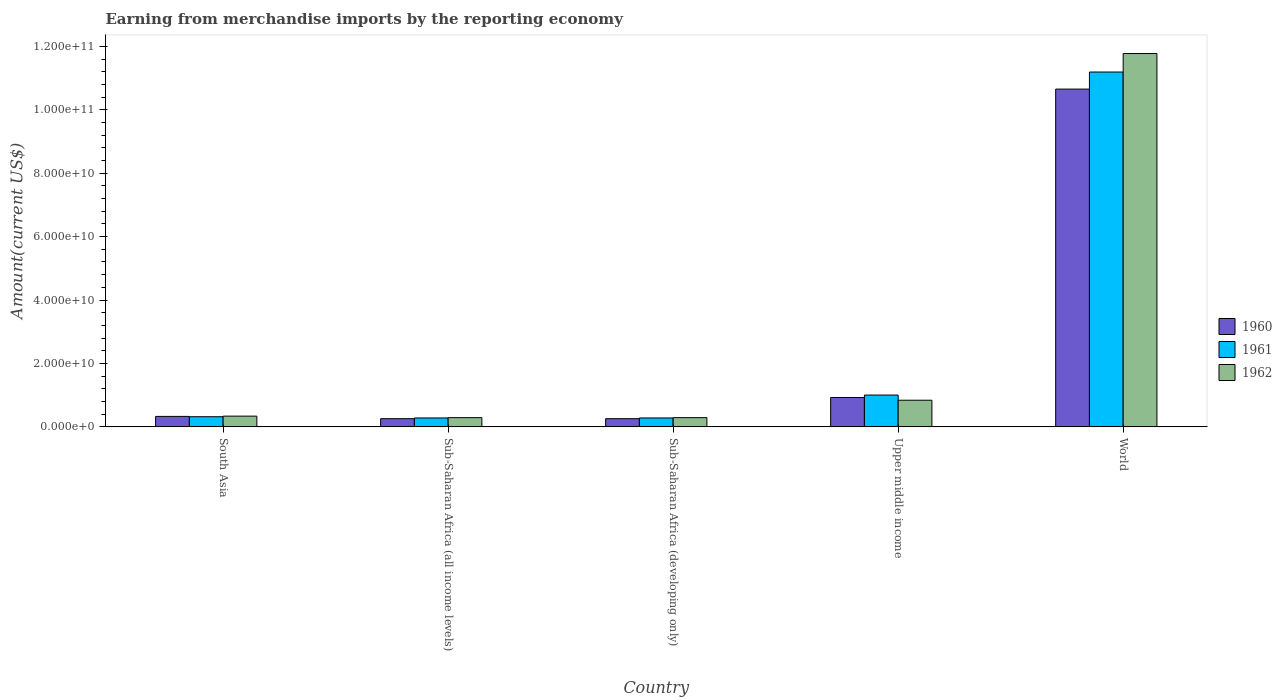How many different coloured bars are there?
Provide a succinct answer. 3. How many groups of bars are there?
Your answer should be compact. 5. Are the number of bars on each tick of the X-axis equal?
Give a very brief answer. Yes. How many bars are there on the 1st tick from the right?
Offer a very short reply. 3. What is the label of the 4th group of bars from the left?
Your answer should be compact. Upper middle income. What is the amount earned from merchandise imports in 1960 in Sub-Saharan Africa (developing only)?
Provide a succinct answer. 2.58e+09. Across all countries, what is the maximum amount earned from merchandise imports in 1961?
Your answer should be compact. 1.12e+11. Across all countries, what is the minimum amount earned from merchandise imports in 1962?
Make the answer very short. 2.91e+09. In which country was the amount earned from merchandise imports in 1960 minimum?
Keep it short and to the point. Sub-Saharan Africa (all income levels). What is the total amount earned from merchandise imports in 1960 in the graph?
Offer a terse response. 1.24e+11. What is the difference between the amount earned from merchandise imports in 1960 in Sub-Saharan Africa (developing only) and the amount earned from merchandise imports in 1962 in South Asia?
Make the answer very short. -8.04e+08. What is the average amount earned from merchandise imports in 1962 per country?
Ensure brevity in your answer.  2.71e+1. What is the difference between the amount earned from merchandise imports of/in 1962 and amount earned from merchandise imports of/in 1960 in Sub-Saharan Africa (all income levels)?
Provide a short and direct response. 3.24e+08. In how many countries, is the amount earned from merchandise imports in 1962 greater than 24000000000 US$?
Make the answer very short. 1. What is the ratio of the amount earned from merchandise imports in 1962 in South Asia to that in Sub-Saharan Africa (developing only)?
Provide a short and direct response. 1.17. Is the amount earned from merchandise imports in 1961 in South Asia less than that in World?
Offer a very short reply. Yes. Is the difference between the amount earned from merchandise imports in 1962 in South Asia and World greater than the difference between the amount earned from merchandise imports in 1960 in South Asia and World?
Ensure brevity in your answer.  No. What is the difference between the highest and the second highest amount earned from merchandise imports in 1960?
Provide a short and direct response. 9.73e+1. What is the difference between the highest and the lowest amount earned from merchandise imports in 1960?
Offer a very short reply. 1.04e+11. Is the sum of the amount earned from merchandise imports in 1960 in South Asia and World greater than the maximum amount earned from merchandise imports in 1961 across all countries?
Your response must be concise. No. How many countries are there in the graph?
Provide a short and direct response. 5. Does the graph contain grids?
Ensure brevity in your answer.  No. Where does the legend appear in the graph?
Provide a short and direct response. Center right. How many legend labels are there?
Your answer should be compact. 3. How are the legend labels stacked?
Your response must be concise. Vertical. What is the title of the graph?
Keep it short and to the point. Earning from merchandise imports by the reporting economy. Does "2015" appear as one of the legend labels in the graph?
Provide a succinct answer. No. What is the label or title of the X-axis?
Provide a short and direct response. Country. What is the label or title of the Y-axis?
Ensure brevity in your answer.  Amount(current US$). What is the Amount(current US$) of 1960 in South Asia?
Your answer should be very brief. 3.30e+09. What is the Amount(current US$) of 1961 in South Asia?
Keep it short and to the point. 3.20e+09. What is the Amount(current US$) of 1962 in South Asia?
Your answer should be compact. 3.39e+09. What is the Amount(current US$) of 1960 in Sub-Saharan Africa (all income levels)?
Give a very brief answer. 2.58e+09. What is the Amount(current US$) of 1961 in Sub-Saharan Africa (all income levels)?
Make the answer very short. 2.81e+09. What is the Amount(current US$) of 1962 in Sub-Saharan Africa (all income levels)?
Your response must be concise. 2.91e+09. What is the Amount(current US$) in 1960 in Sub-Saharan Africa (developing only)?
Provide a succinct answer. 2.58e+09. What is the Amount(current US$) of 1961 in Sub-Saharan Africa (developing only)?
Offer a very short reply. 2.81e+09. What is the Amount(current US$) in 1962 in Sub-Saharan Africa (developing only)?
Make the answer very short. 2.91e+09. What is the Amount(current US$) of 1960 in Upper middle income?
Offer a terse response. 9.26e+09. What is the Amount(current US$) of 1961 in Upper middle income?
Provide a succinct answer. 1.00e+1. What is the Amount(current US$) in 1962 in Upper middle income?
Give a very brief answer. 8.41e+09. What is the Amount(current US$) in 1960 in World?
Give a very brief answer. 1.07e+11. What is the Amount(current US$) in 1961 in World?
Your answer should be compact. 1.12e+11. What is the Amount(current US$) of 1962 in World?
Give a very brief answer. 1.18e+11. Across all countries, what is the maximum Amount(current US$) of 1960?
Give a very brief answer. 1.07e+11. Across all countries, what is the maximum Amount(current US$) of 1961?
Keep it short and to the point. 1.12e+11. Across all countries, what is the maximum Amount(current US$) of 1962?
Your answer should be very brief. 1.18e+11. Across all countries, what is the minimum Amount(current US$) in 1960?
Offer a very short reply. 2.58e+09. Across all countries, what is the minimum Amount(current US$) in 1961?
Make the answer very short. 2.81e+09. Across all countries, what is the minimum Amount(current US$) of 1962?
Provide a succinct answer. 2.91e+09. What is the total Amount(current US$) in 1960 in the graph?
Ensure brevity in your answer.  1.24e+11. What is the total Amount(current US$) of 1961 in the graph?
Offer a terse response. 1.31e+11. What is the total Amount(current US$) in 1962 in the graph?
Offer a terse response. 1.35e+11. What is the difference between the Amount(current US$) of 1960 in South Asia and that in Sub-Saharan Africa (all income levels)?
Offer a very short reply. 7.19e+08. What is the difference between the Amount(current US$) in 1961 in South Asia and that in Sub-Saharan Africa (all income levels)?
Keep it short and to the point. 3.92e+08. What is the difference between the Amount(current US$) of 1962 in South Asia and that in Sub-Saharan Africa (all income levels)?
Ensure brevity in your answer.  4.80e+08. What is the difference between the Amount(current US$) of 1960 in South Asia and that in Sub-Saharan Africa (developing only)?
Your response must be concise. 7.19e+08. What is the difference between the Amount(current US$) in 1961 in South Asia and that in Sub-Saharan Africa (developing only)?
Provide a succinct answer. 3.92e+08. What is the difference between the Amount(current US$) of 1962 in South Asia and that in Sub-Saharan Africa (developing only)?
Your answer should be very brief. 4.80e+08. What is the difference between the Amount(current US$) in 1960 in South Asia and that in Upper middle income?
Offer a very short reply. -5.96e+09. What is the difference between the Amount(current US$) of 1961 in South Asia and that in Upper middle income?
Your answer should be compact. -6.83e+09. What is the difference between the Amount(current US$) of 1962 in South Asia and that in Upper middle income?
Make the answer very short. -5.02e+09. What is the difference between the Amount(current US$) in 1960 in South Asia and that in World?
Ensure brevity in your answer.  -1.03e+11. What is the difference between the Amount(current US$) in 1961 in South Asia and that in World?
Keep it short and to the point. -1.09e+11. What is the difference between the Amount(current US$) of 1962 in South Asia and that in World?
Ensure brevity in your answer.  -1.14e+11. What is the difference between the Amount(current US$) of 1961 in Sub-Saharan Africa (all income levels) and that in Sub-Saharan Africa (developing only)?
Your response must be concise. 0. What is the difference between the Amount(current US$) in 1962 in Sub-Saharan Africa (all income levels) and that in Sub-Saharan Africa (developing only)?
Your answer should be compact. 0. What is the difference between the Amount(current US$) in 1960 in Sub-Saharan Africa (all income levels) and that in Upper middle income?
Keep it short and to the point. -6.68e+09. What is the difference between the Amount(current US$) in 1961 in Sub-Saharan Africa (all income levels) and that in Upper middle income?
Keep it short and to the point. -7.22e+09. What is the difference between the Amount(current US$) of 1962 in Sub-Saharan Africa (all income levels) and that in Upper middle income?
Your answer should be very brief. -5.50e+09. What is the difference between the Amount(current US$) of 1960 in Sub-Saharan Africa (all income levels) and that in World?
Offer a terse response. -1.04e+11. What is the difference between the Amount(current US$) in 1961 in Sub-Saharan Africa (all income levels) and that in World?
Your response must be concise. -1.09e+11. What is the difference between the Amount(current US$) of 1962 in Sub-Saharan Africa (all income levels) and that in World?
Your answer should be compact. -1.15e+11. What is the difference between the Amount(current US$) of 1960 in Sub-Saharan Africa (developing only) and that in Upper middle income?
Your answer should be compact. -6.68e+09. What is the difference between the Amount(current US$) in 1961 in Sub-Saharan Africa (developing only) and that in Upper middle income?
Ensure brevity in your answer.  -7.22e+09. What is the difference between the Amount(current US$) in 1962 in Sub-Saharan Africa (developing only) and that in Upper middle income?
Provide a short and direct response. -5.50e+09. What is the difference between the Amount(current US$) of 1960 in Sub-Saharan Africa (developing only) and that in World?
Ensure brevity in your answer.  -1.04e+11. What is the difference between the Amount(current US$) in 1961 in Sub-Saharan Africa (developing only) and that in World?
Your response must be concise. -1.09e+11. What is the difference between the Amount(current US$) in 1962 in Sub-Saharan Africa (developing only) and that in World?
Provide a short and direct response. -1.15e+11. What is the difference between the Amount(current US$) of 1960 in Upper middle income and that in World?
Offer a terse response. -9.73e+1. What is the difference between the Amount(current US$) in 1961 in Upper middle income and that in World?
Offer a terse response. -1.02e+11. What is the difference between the Amount(current US$) of 1962 in Upper middle income and that in World?
Offer a terse response. -1.09e+11. What is the difference between the Amount(current US$) in 1960 in South Asia and the Amount(current US$) in 1961 in Sub-Saharan Africa (all income levels)?
Keep it short and to the point. 4.92e+08. What is the difference between the Amount(current US$) in 1960 in South Asia and the Amount(current US$) in 1962 in Sub-Saharan Africa (all income levels)?
Offer a very short reply. 3.95e+08. What is the difference between the Amount(current US$) in 1961 in South Asia and the Amount(current US$) in 1962 in Sub-Saharan Africa (all income levels)?
Provide a short and direct response. 2.95e+08. What is the difference between the Amount(current US$) of 1960 in South Asia and the Amount(current US$) of 1961 in Sub-Saharan Africa (developing only)?
Give a very brief answer. 4.92e+08. What is the difference between the Amount(current US$) of 1960 in South Asia and the Amount(current US$) of 1962 in Sub-Saharan Africa (developing only)?
Provide a succinct answer. 3.95e+08. What is the difference between the Amount(current US$) in 1961 in South Asia and the Amount(current US$) in 1962 in Sub-Saharan Africa (developing only)?
Your answer should be very brief. 2.95e+08. What is the difference between the Amount(current US$) of 1960 in South Asia and the Amount(current US$) of 1961 in Upper middle income?
Ensure brevity in your answer.  -6.73e+09. What is the difference between the Amount(current US$) in 1960 in South Asia and the Amount(current US$) in 1962 in Upper middle income?
Your response must be concise. -5.10e+09. What is the difference between the Amount(current US$) in 1961 in South Asia and the Amount(current US$) in 1962 in Upper middle income?
Your answer should be very brief. -5.20e+09. What is the difference between the Amount(current US$) in 1960 in South Asia and the Amount(current US$) in 1961 in World?
Offer a terse response. -1.09e+11. What is the difference between the Amount(current US$) of 1960 in South Asia and the Amount(current US$) of 1962 in World?
Offer a terse response. -1.14e+11. What is the difference between the Amount(current US$) in 1961 in South Asia and the Amount(current US$) in 1962 in World?
Make the answer very short. -1.15e+11. What is the difference between the Amount(current US$) in 1960 in Sub-Saharan Africa (all income levels) and the Amount(current US$) in 1961 in Sub-Saharan Africa (developing only)?
Ensure brevity in your answer.  -2.27e+08. What is the difference between the Amount(current US$) in 1960 in Sub-Saharan Africa (all income levels) and the Amount(current US$) in 1962 in Sub-Saharan Africa (developing only)?
Make the answer very short. -3.24e+08. What is the difference between the Amount(current US$) in 1961 in Sub-Saharan Africa (all income levels) and the Amount(current US$) in 1962 in Sub-Saharan Africa (developing only)?
Make the answer very short. -9.68e+07. What is the difference between the Amount(current US$) of 1960 in Sub-Saharan Africa (all income levels) and the Amount(current US$) of 1961 in Upper middle income?
Your answer should be compact. -7.45e+09. What is the difference between the Amount(current US$) of 1960 in Sub-Saharan Africa (all income levels) and the Amount(current US$) of 1962 in Upper middle income?
Your response must be concise. -5.82e+09. What is the difference between the Amount(current US$) of 1961 in Sub-Saharan Africa (all income levels) and the Amount(current US$) of 1962 in Upper middle income?
Offer a terse response. -5.60e+09. What is the difference between the Amount(current US$) of 1960 in Sub-Saharan Africa (all income levels) and the Amount(current US$) of 1961 in World?
Provide a short and direct response. -1.09e+11. What is the difference between the Amount(current US$) of 1960 in Sub-Saharan Africa (all income levels) and the Amount(current US$) of 1962 in World?
Your response must be concise. -1.15e+11. What is the difference between the Amount(current US$) of 1961 in Sub-Saharan Africa (all income levels) and the Amount(current US$) of 1962 in World?
Your response must be concise. -1.15e+11. What is the difference between the Amount(current US$) in 1960 in Sub-Saharan Africa (developing only) and the Amount(current US$) in 1961 in Upper middle income?
Give a very brief answer. -7.45e+09. What is the difference between the Amount(current US$) in 1960 in Sub-Saharan Africa (developing only) and the Amount(current US$) in 1962 in Upper middle income?
Offer a very short reply. -5.82e+09. What is the difference between the Amount(current US$) of 1961 in Sub-Saharan Africa (developing only) and the Amount(current US$) of 1962 in Upper middle income?
Your answer should be compact. -5.60e+09. What is the difference between the Amount(current US$) in 1960 in Sub-Saharan Africa (developing only) and the Amount(current US$) in 1961 in World?
Your answer should be very brief. -1.09e+11. What is the difference between the Amount(current US$) in 1960 in Sub-Saharan Africa (developing only) and the Amount(current US$) in 1962 in World?
Provide a short and direct response. -1.15e+11. What is the difference between the Amount(current US$) of 1961 in Sub-Saharan Africa (developing only) and the Amount(current US$) of 1962 in World?
Provide a short and direct response. -1.15e+11. What is the difference between the Amount(current US$) in 1960 in Upper middle income and the Amount(current US$) in 1961 in World?
Your response must be concise. -1.03e+11. What is the difference between the Amount(current US$) of 1960 in Upper middle income and the Amount(current US$) of 1962 in World?
Provide a succinct answer. -1.08e+11. What is the difference between the Amount(current US$) of 1961 in Upper middle income and the Amount(current US$) of 1962 in World?
Your answer should be compact. -1.08e+11. What is the average Amount(current US$) of 1960 per country?
Ensure brevity in your answer.  2.49e+1. What is the average Amount(current US$) of 1961 per country?
Keep it short and to the point. 2.62e+1. What is the average Amount(current US$) of 1962 per country?
Offer a very short reply. 2.71e+1. What is the difference between the Amount(current US$) in 1960 and Amount(current US$) in 1961 in South Asia?
Your response must be concise. 1.00e+08. What is the difference between the Amount(current US$) of 1960 and Amount(current US$) of 1962 in South Asia?
Provide a succinct answer. -8.46e+07. What is the difference between the Amount(current US$) in 1961 and Amount(current US$) in 1962 in South Asia?
Provide a succinct answer. -1.85e+08. What is the difference between the Amount(current US$) in 1960 and Amount(current US$) in 1961 in Sub-Saharan Africa (all income levels)?
Your answer should be very brief. -2.27e+08. What is the difference between the Amount(current US$) of 1960 and Amount(current US$) of 1962 in Sub-Saharan Africa (all income levels)?
Give a very brief answer. -3.24e+08. What is the difference between the Amount(current US$) in 1961 and Amount(current US$) in 1962 in Sub-Saharan Africa (all income levels)?
Make the answer very short. -9.68e+07. What is the difference between the Amount(current US$) in 1960 and Amount(current US$) in 1961 in Sub-Saharan Africa (developing only)?
Your answer should be compact. -2.27e+08. What is the difference between the Amount(current US$) of 1960 and Amount(current US$) of 1962 in Sub-Saharan Africa (developing only)?
Your answer should be very brief. -3.24e+08. What is the difference between the Amount(current US$) of 1961 and Amount(current US$) of 1962 in Sub-Saharan Africa (developing only)?
Your answer should be compact. -9.68e+07. What is the difference between the Amount(current US$) in 1960 and Amount(current US$) in 1961 in Upper middle income?
Your response must be concise. -7.73e+08. What is the difference between the Amount(current US$) in 1960 and Amount(current US$) in 1962 in Upper middle income?
Offer a very short reply. 8.55e+08. What is the difference between the Amount(current US$) of 1961 and Amount(current US$) of 1962 in Upper middle income?
Your response must be concise. 1.63e+09. What is the difference between the Amount(current US$) of 1960 and Amount(current US$) of 1961 in World?
Keep it short and to the point. -5.38e+09. What is the difference between the Amount(current US$) of 1960 and Amount(current US$) of 1962 in World?
Keep it short and to the point. -1.12e+1. What is the difference between the Amount(current US$) in 1961 and Amount(current US$) in 1962 in World?
Your response must be concise. -5.83e+09. What is the ratio of the Amount(current US$) in 1960 in South Asia to that in Sub-Saharan Africa (all income levels)?
Your answer should be very brief. 1.28. What is the ratio of the Amount(current US$) in 1961 in South Asia to that in Sub-Saharan Africa (all income levels)?
Keep it short and to the point. 1.14. What is the ratio of the Amount(current US$) in 1962 in South Asia to that in Sub-Saharan Africa (all income levels)?
Provide a short and direct response. 1.17. What is the ratio of the Amount(current US$) of 1960 in South Asia to that in Sub-Saharan Africa (developing only)?
Offer a very short reply. 1.28. What is the ratio of the Amount(current US$) in 1961 in South Asia to that in Sub-Saharan Africa (developing only)?
Keep it short and to the point. 1.14. What is the ratio of the Amount(current US$) of 1962 in South Asia to that in Sub-Saharan Africa (developing only)?
Provide a short and direct response. 1.17. What is the ratio of the Amount(current US$) in 1960 in South Asia to that in Upper middle income?
Your response must be concise. 0.36. What is the ratio of the Amount(current US$) in 1961 in South Asia to that in Upper middle income?
Offer a terse response. 0.32. What is the ratio of the Amount(current US$) in 1962 in South Asia to that in Upper middle income?
Offer a terse response. 0.4. What is the ratio of the Amount(current US$) of 1960 in South Asia to that in World?
Offer a terse response. 0.03. What is the ratio of the Amount(current US$) of 1961 in South Asia to that in World?
Keep it short and to the point. 0.03. What is the ratio of the Amount(current US$) of 1962 in South Asia to that in World?
Your answer should be compact. 0.03. What is the ratio of the Amount(current US$) in 1962 in Sub-Saharan Africa (all income levels) to that in Sub-Saharan Africa (developing only)?
Offer a terse response. 1. What is the ratio of the Amount(current US$) in 1960 in Sub-Saharan Africa (all income levels) to that in Upper middle income?
Your answer should be compact. 0.28. What is the ratio of the Amount(current US$) of 1961 in Sub-Saharan Africa (all income levels) to that in Upper middle income?
Make the answer very short. 0.28. What is the ratio of the Amount(current US$) in 1962 in Sub-Saharan Africa (all income levels) to that in Upper middle income?
Provide a succinct answer. 0.35. What is the ratio of the Amount(current US$) of 1960 in Sub-Saharan Africa (all income levels) to that in World?
Your answer should be compact. 0.02. What is the ratio of the Amount(current US$) in 1961 in Sub-Saharan Africa (all income levels) to that in World?
Offer a terse response. 0.03. What is the ratio of the Amount(current US$) of 1962 in Sub-Saharan Africa (all income levels) to that in World?
Give a very brief answer. 0.02. What is the ratio of the Amount(current US$) in 1960 in Sub-Saharan Africa (developing only) to that in Upper middle income?
Make the answer very short. 0.28. What is the ratio of the Amount(current US$) of 1961 in Sub-Saharan Africa (developing only) to that in Upper middle income?
Your answer should be compact. 0.28. What is the ratio of the Amount(current US$) of 1962 in Sub-Saharan Africa (developing only) to that in Upper middle income?
Your answer should be very brief. 0.35. What is the ratio of the Amount(current US$) in 1960 in Sub-Saharan Africa (developing only) to that in World?
Offer a very short reply. 0.02. What is the ratio of the Amount(current US$) of 1961 in Sub-Saharan Africa (developing only) to that in World?
Offer a very short reply. 0.03. What is the ratio of the Amount(current US$) of 1962 in Sub-Saharan Africa (developing only) to that in World?
Keep it short and to the point. 0.02. What is the ratio of the Amount(current US$) of 1960 in Upper middle income to that in World?
Provide a short and direct response. 0.09. What is the ratio of the Amount(current US$) of 1961 in Upper middle income to that in World?
Your answer should be compact. 0.09. What is the ratio of the Amount(current US$) in 1962 in Upper middle income to that in World?
Provide a short and direct response. 0.07. What is the difference between the highest and the second highest Amount(current US$) in 1960?
Ensure brevity in your answer.  9.73e+1. What is the difference between the highest and the second highest Amount(current US$) of 1961?
Offer a terse response. 1.02e+11. What is the difference between the highest and the second highest Amount(current US$) in 1962?
Offer a very short reply. 1.09e+11. What is the difference between the highest and the lowest Amount(current US$) of 1960?
Your answer should be compact. 1.04e+11. What is the difference between the highest and the lowest Amount(current US$) of 1961?
Your answer should be very brief. 1.09e+11. What is the difference between the highest and the lowest Amount(current US$) of 1962?
Offer a terse response. 1.15e+11. 